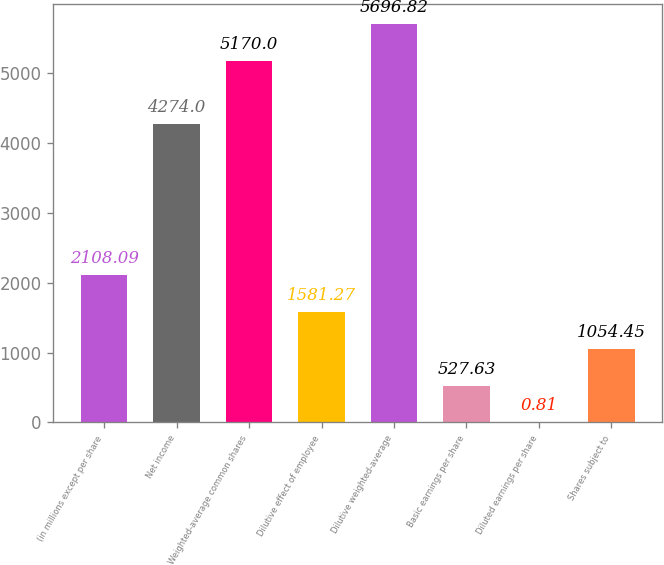Convert chart to OTSL. <chart><loc_0><loc_0><loc_500><loc_500><bar_chart><fcel>(in millions except per share<fcel>Net income<fcel>Weighted-average common shares<fcel>Dilutive effect of employee<fcel>Dilutive weighted-average<fcel>Basic earnings per share<fcel>Diluted earnings per share<fcel>Shares subject to<nl><fcel>2108.09<fcel>4274<fcel>5170<fcel>1581.27<fcel>5696.82<fcel>527.63<fcel>0.81<fcel>1054.45<nl></chart> 